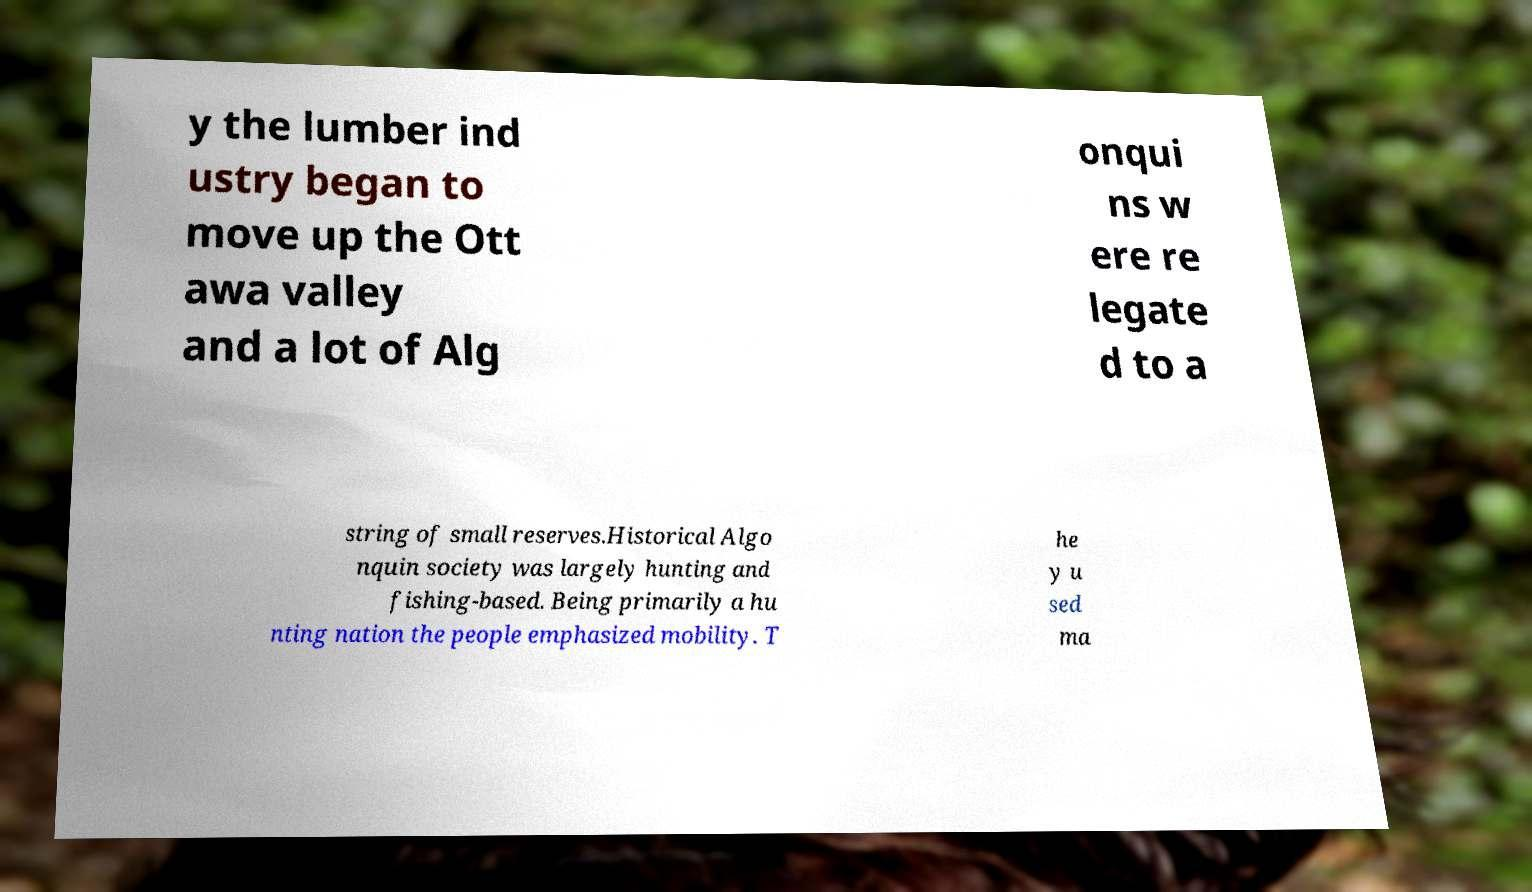Please identify and transcribe the text found in this image. y the lumber ind ustry began to move up the Ott awa valley and a lot of Alg onqui ns w ere re legate d to a string of small reserves.Historical Algo nquin society was largely hunting and fishing-based. Being primarily a hu nting nation the people emphasized mobility. T he y u sed ma 